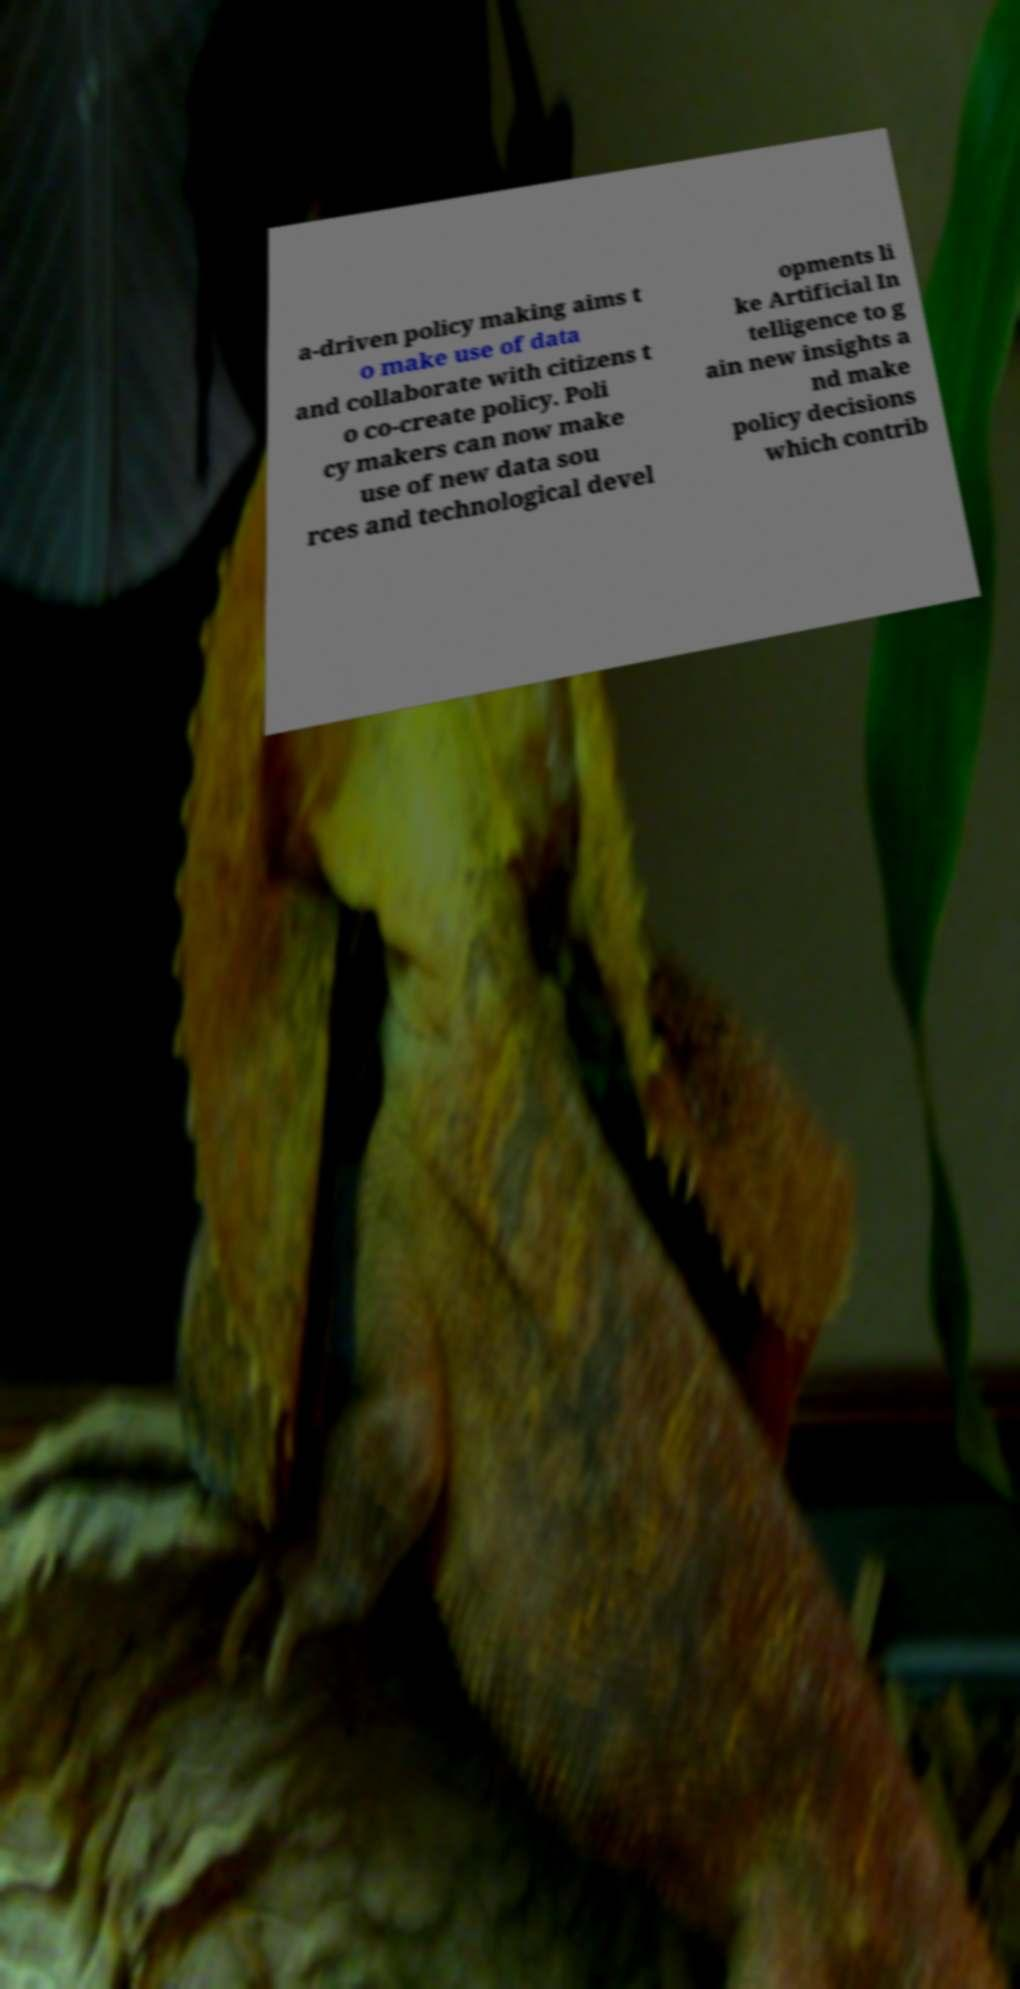There's text embedded in this image that I need extracted. Can you transcribe it verbatim? a-driven policy making aims t o make use of data and collaborate with citizens t o co-create policy. Poli cy makers can now make use of new data sou rces and technological devel opments li ke Artificial In telligence to g ain new insights a nd make policy decisions which contrib 